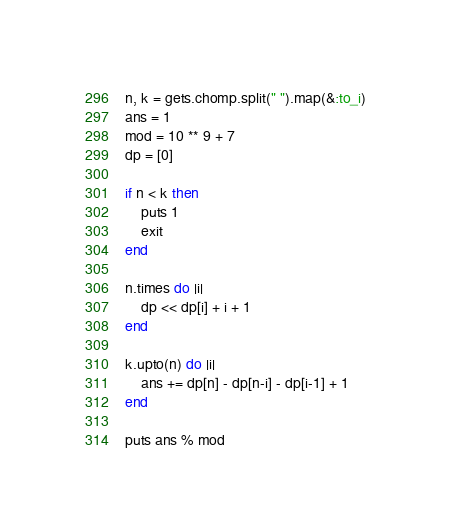Convert code to text. <code><loc_0><loc_0><loc_500><loc_500><_Ruby_>n, k = gets.chomp.split(" ").map(&:to_i)
ans = 1
mod = 10 ** 9 + 7
dp = [0]

if n < k then
    puts 1
    exit
end

n.times do |i|
    dp << dp[i] + i + 1
end

k.upto(n) do |i|
    ans += dp[n] - dp[n-i] - dp[i-1] + 1
end

puts ans % mod</code> 